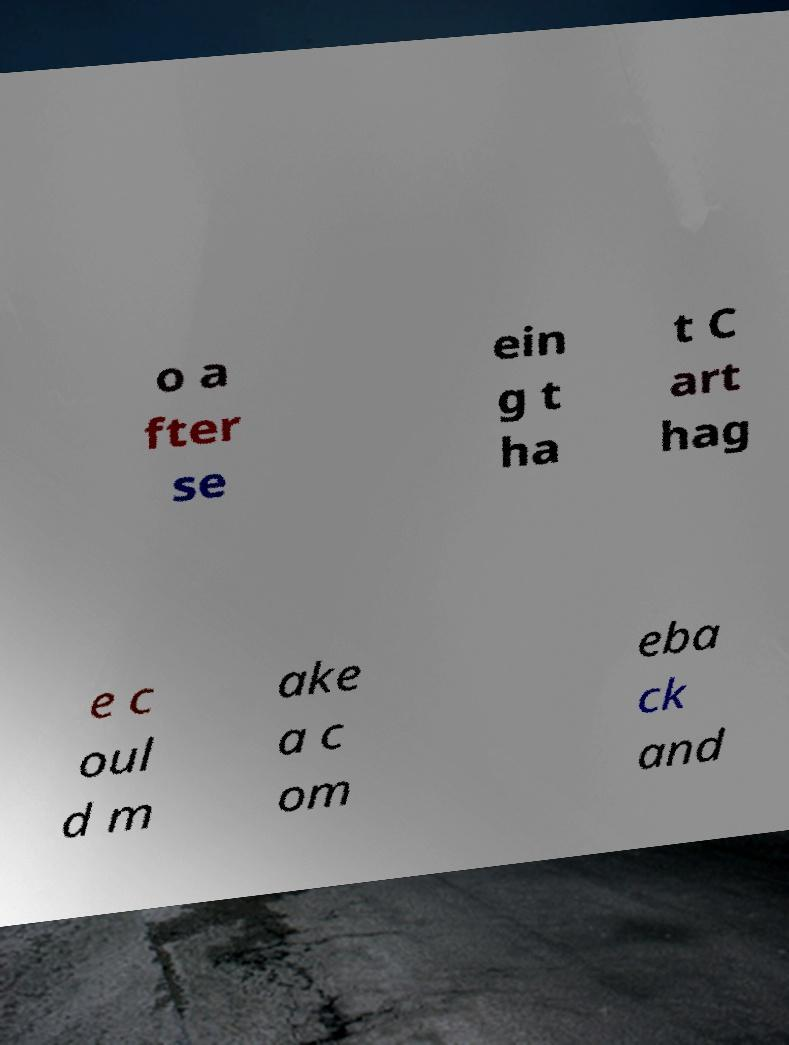Please read and relay the text visible in this image. What does it say? o a fter se ein g t ha t C art hag e c oul d m ake a c om eba ck and 